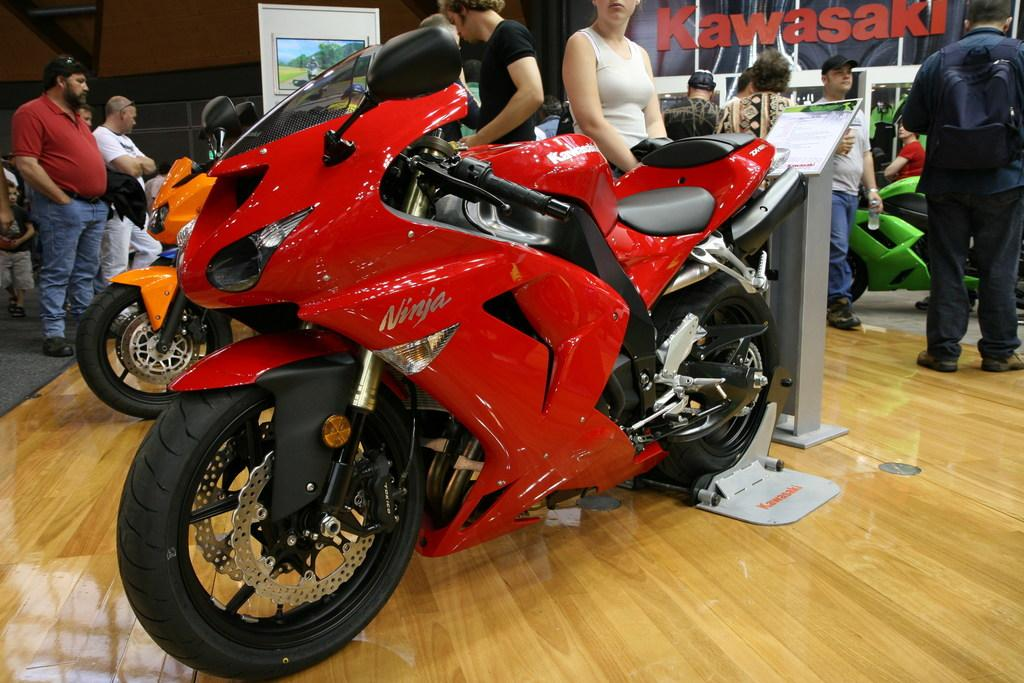What objects are on the floor in the image? There are bikes on the floor in the image. What can be seen in the background of the image? There are people and a wall in the background of the image. What else is present in the background of the image? There are boards in the background of the image. Who is the owner of the talking apparatus in the image? There is no talking apparatus present in the image. 